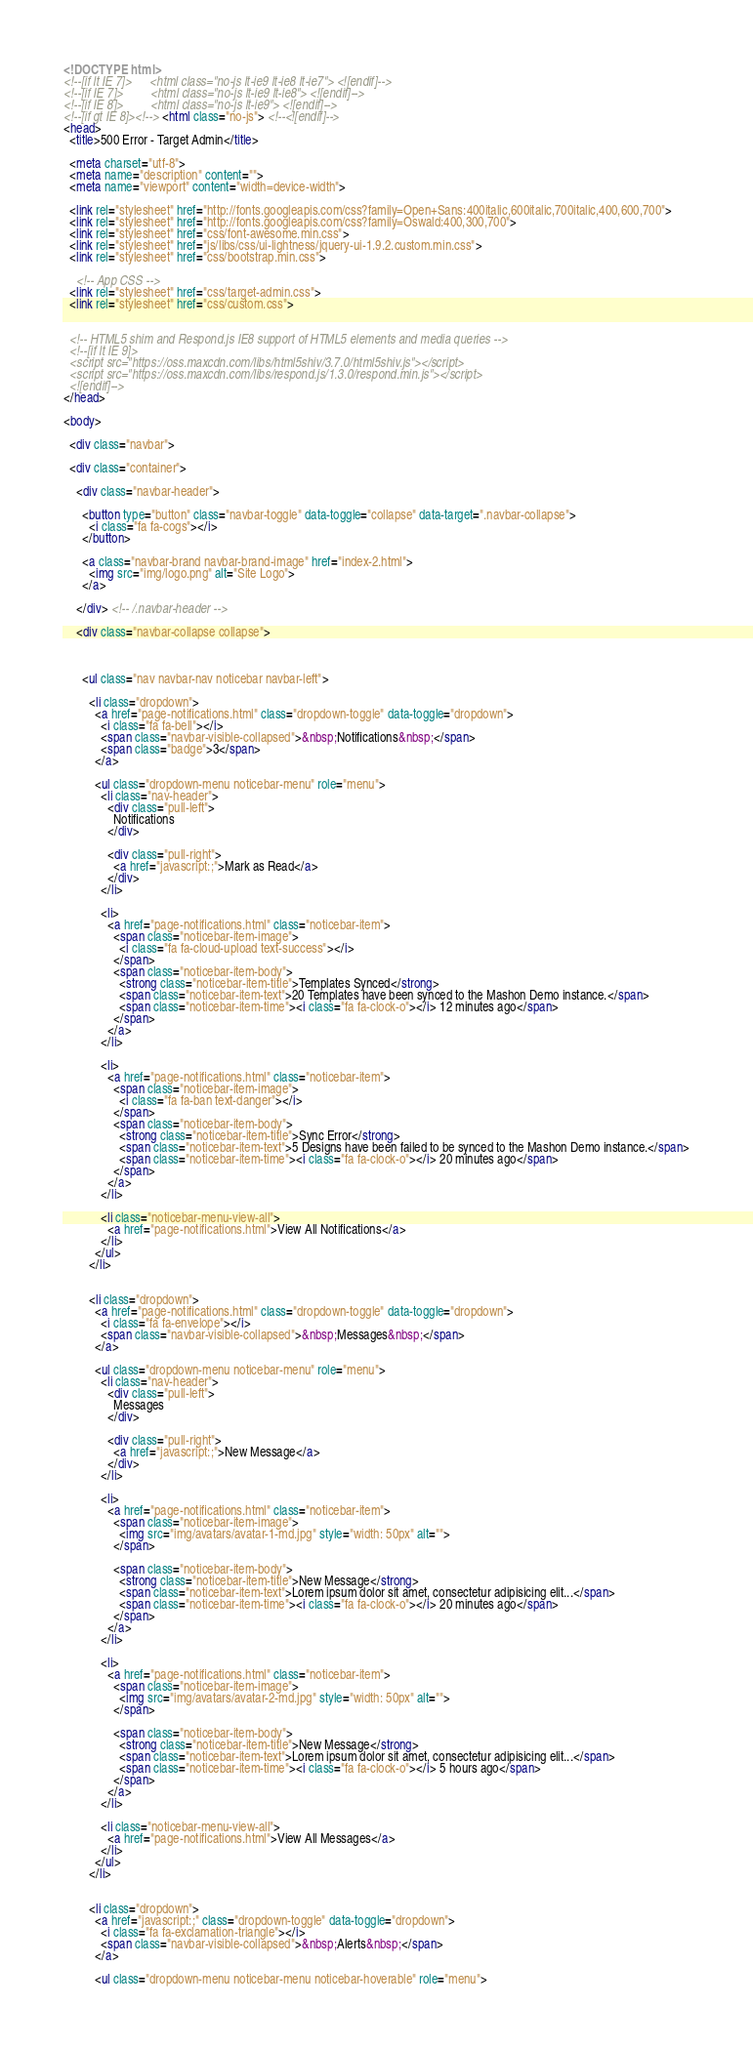<code> <loc_0><loc_0><loc_500><loc_500><_HTML_><!DOCTYPE html>
<!--[if lt IE 7]>      <html class="no-js lt-ie9 lt-ie8 lt-ie7"> <![endif]-->
<!--[if IE 7]>         <html class="no-js lt-ie9 lt-ie8"> <![endif]-->
<!--[if IE 8]>         <html class="no-js lt-ie9"> <![endif]-->
<!--[if gt IE 8]><!--> <html class="no-js"> <!--<![endif]-->
<head>
  <title>500 Error - Target Admin</title>

  <meta charset="utf-8">
  <meta name="description" content="">
  <meta name="viewport" content="width=device-width">

  <link rel="stylesheet" href="http://fonts.googleapis.com/css?family=Open+Sans:400italic,600italic,700italic,400,600,700">
  <link rel="stylesheet" href="http://fonts.googleapis.com/css?family=Oswald:400,300,700">
  <link rel="stylesheet" href="css/font-awesome.min.css">
  <link rel="stylesheet" href="js/libs/css/ui-lightness/jquery-ui-1.9.2.custom.min.css">
  <link rel="stylesheet" href="css/bootstrap.min.css">

    <!-- App CSS -->
  <link rel="stylesheet" href="css/target-admin.css">
  <link rel="stylesheet" href="css/custom.css">


  <!-- HTML5 shim and Respond.js IE8 support of HTML5 elements and media queries -->
  <!--[if lt IE 9]>
  <script src="https://oss.maxcdn.com/libs/html5shiv/3.7.0/html5shiv.js"></script>
  <script src="https://oss.maxcdn.com/libs/respond.js/1.3.0/respond.min.js"></script>
  <![endif]-->
</head>

<body>

  <div class="navbar">

  <div class="container">

    <div class="navbar-header">

      <button type="button" class="navbar-toggle" data-toggle="collapse" data-target=".navbar-collapse">
        <i class="fa fa-cogs"></i>
      </button>

      <a class="navbar-brand navbar-brand-image" href="index-2.html">
        <img src="img/logo.png" alt="Site Logo">
      </a>

    </div> <!-- /.navbar-header -->

    <div class="navbar-collapse collapse">

      

      <ul class="nav navbar-nav noticebar navbar-left">

        <li class="dropdown">
          <a href="page-notifications.html" class="dropdown-toggle" data-toggle="dropdown">
            <i class="fa fa-bell"></i>
            <span class="navbar-visible-collapsed">&nbsp;Notifications&nbsp;</span>
            <span class="badge">3</span>
          </a>

          <ul class="dropdown-menu noticebar-menu" role="menu">
            <li class="nav-header">
              <div class="pull-left">
                Notifications
              </div>

              <div class="pull-right">
                <a href="javascript:;">Mark as Read</a>
              </div>
            </li>

            <li>
              <a href="page-notifications.html" class="noticebar-item">
                <span class="noticebar-item-image">
                  <i class="fa fa-cloud-upload text-success"></i>
                </span>
                <span class="noticebar-item-body">
                  <strong class="noticebar-item-title">Templates Synced</strong>
                  <span class="noticebar-item-text">20 Templates have been synced to the Mashon Demo instance.</span>
                  <span class="noticebar-item-time"><i class="fa fa-clock-o"></i> 12 minutes ago</span>
                </span>
              </a>
            </li>

            <li>
              <a href="page-notifications.html" class="noticebar-item">
                <span class="noticebar-item-image">
                  <i class="fa fa-ban text-danger"></i>
                </span>
                <span class="noticebar-item-body">
                  <strong class="noticebar-item-title">Sync Error</strong>
                  <span class="noticebar-item-text">5 Designs have been failed to be synced to the Mashon Demo instance.</span>
                  <span class="noticebar-item-time"><i class="fa fa-clock-o"></i> 20 minutes ago</span>
                </span>
              </a>
            </li>

            <li class="noticebar-menu-view-all">
              <a href="page-notifications.html">View All Notifications</a>
            </li>
          </ul>
        </li>


        <li class="dropdown">
          <a href="page-notifications.html" class="dropdown-toggle" data-toggle="dropdown">
            <i class="fa fa-envelope"></i>
            <span class="navbar-visible-collapsed">&nbsp;Messages&nbsp;</span>
          </a>

          <ul class="dropdown-menu noticebar-menu" role="menu">                
            <li class="nav-header">
              <div class="pull-left">
                Messages
              </div>

              <div class="pull-right">
                <a href="javascript:;">New Message</a>
              </div>
            </li>

            <li>
              <a href="page-notifications.html" class="noticebar-item">
                <span class="noticebar-item-image">
                  <img src="img/avatars/avatar-1-md.jpg" style="width: 50px" alt="">
                </span>

                <span class="noticebar-item-body">
                  <strong class="noticebar-item-title">New Message</strong>
                  <span class="noticebar-item-text">Lorem ipsum dolor sit amet, consectetur adipisicing elit...</span>
                  <span class="noticebar-item-time"><i class="fa fa-clock-o"></i> 20 minutes ago</span>
                </span>
              </a>
            </li>

            <li>
              <a href="page-notifications.html" class="noticebar-item">
                <span class="noticebar-item-image">
                  <img src="img/avatars/avatar-2-md.jpg" style="width: 50px" alt="">
                </span>

                <span class="noticebar-item-body">
                  <strong class="noticebar-item-title">New Message</strong>
                  <span class="noticebar-item-text">Lorem ipsum dolor sit amet, consectetur adipisicing elit...</span>
                  <span class="noticebar-item-time"><i class="fa fa-clock-o"></i> 5 hours ago</span>
                </span>
              </a>
            </li>

            <li class="noticebar-menu-view-all">
              <a href="page-notifications.html">View All Messages</a>
            </li>
          </ul>
        </li>


        <li class="dropdown">
          <a href="javascript:;" class="dropdown-toggle" data-toggle="dropdown">
            <i class="fa fa-exclamation-triangle"></i>
            <span class="navbar-visible-collapsed">&nbsp;Alerts&nbsp;</span>
          </a>

          <ul class="dropdown-menu noticebar-menu noticebar-hoverable" role="menu">                </code> 